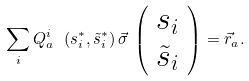Convert formula to latex. <formula><loc_0><loc_0><loc_500><loc_500>\sum _ { i } Q ^ { i } _ { a } \ ( s ^ { * } _ { i } , \tilde { s } ^ { * } _ { i } ) \, \vec { \sigma } \, \left ( \begin{array} { c } s _ { i } \\ \tilde { s } _ { i } \end{array} \right ) = \vec { r } _ { a } .</formula> 